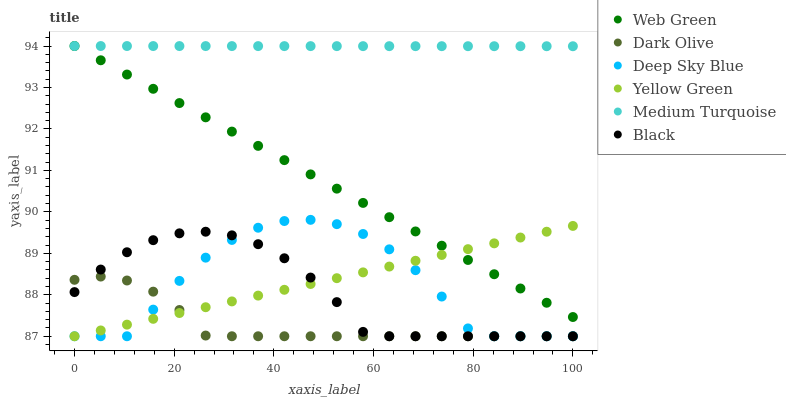Does Dark Olive have the minimum area under the curve?
Answer yes or no. Yes. Does Medium Turquoise have the maximum area under the curve?
Answer yes or no. Yes. Does Web Green have the minimum area under the curve?
Answer yes or no. No. Does Web Green have the maximum area under the curve?
Answer yes or no. No. Is Yellow Green the smoothest?
Answer yes or no. Yes. Is Deep Sky Blue the roughest?
Answer yes or no. Yes. Is Dark Olive the smoothest?
Answer yes or no. No. Is Dark Olive the roughest?
Answer yes or no. No. Does Deep Sky Blue have the lowest value?
Answer yes or no. Yes. Does Web Green have the lowest value?
Answer yes or no. No. Does Medium Turquoise have the highest value?
Answer yes or no. Yes. Does Dark Olive have the highest value?
Answer yes or no. No. Is Deep Sky Blue less than Web Green?
Answer yes or no. Yes. Is Web Green greater than Deep Sky Blue?
Answer yes or no. Yes. Does Yellow Green intersect Deep Sky Blue?
Answer yes or no. Yes. Is Yellow Green less than Deep Sky Blue?
Answer yes or no. No. Is Yellow Green greater than Deep Sky Blue?
Answer yes or no. No. Does Deep Sky Blue intersect Web Green?
Answer yes or no. No. 